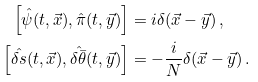<formula> <loc_0><loc_0><loc_500><loc_500>\left [ \hat { \psi } ( t , \vec { x } ) , \hat { \pi } ( t , \vec { y } ) \right ] & = i \delta ( \vec { x } - \vec { y } ) \, , \\ \left [ \hat { \delta s } ( t , \vec { x } ) , \hat { \delta \bar { \theta } } ( t , \vec { y } ) \right ] & = - \frac { i } { N } \delta ( \vec { x } - \vec { y } ) \, .</formula> 